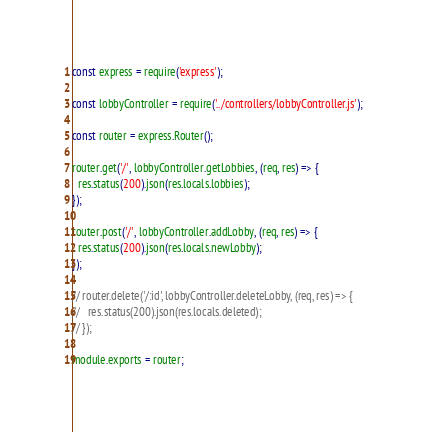Convert code to text. <code><loc_0><loc_0><loc_500><loc_500><_JavaScript_>const express = require('express');

const lobbyController = require('../controllers/lobbyController.js');

const router = express.Router();

router.get('/', lobbyController.getLobbies, (req, res) => {
  res.status(200).json(res.locals.lobbies);
});

router.post('/', lobbyController.addLobby, (req, res) => {
  res.status(200).json(res.locals.newLobby);
});

// router.delete('/:id', lobbyController.deleteLobby, (req, res) => {
//   res.status(200).json(res.locals.deleted);
// });

module.exports = router;
</code> 